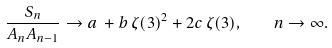<formula> <loc_0><loc_0><loc_500><loc_500>\frac { S _ { n } } { A _ { n } A _ { n - 1 } } \to a \, + b \, \zeta ( 3 ) ^ { 2 } + 2 c \, \zeta ( 3 ) , \quad n \to \infty .</formula> 